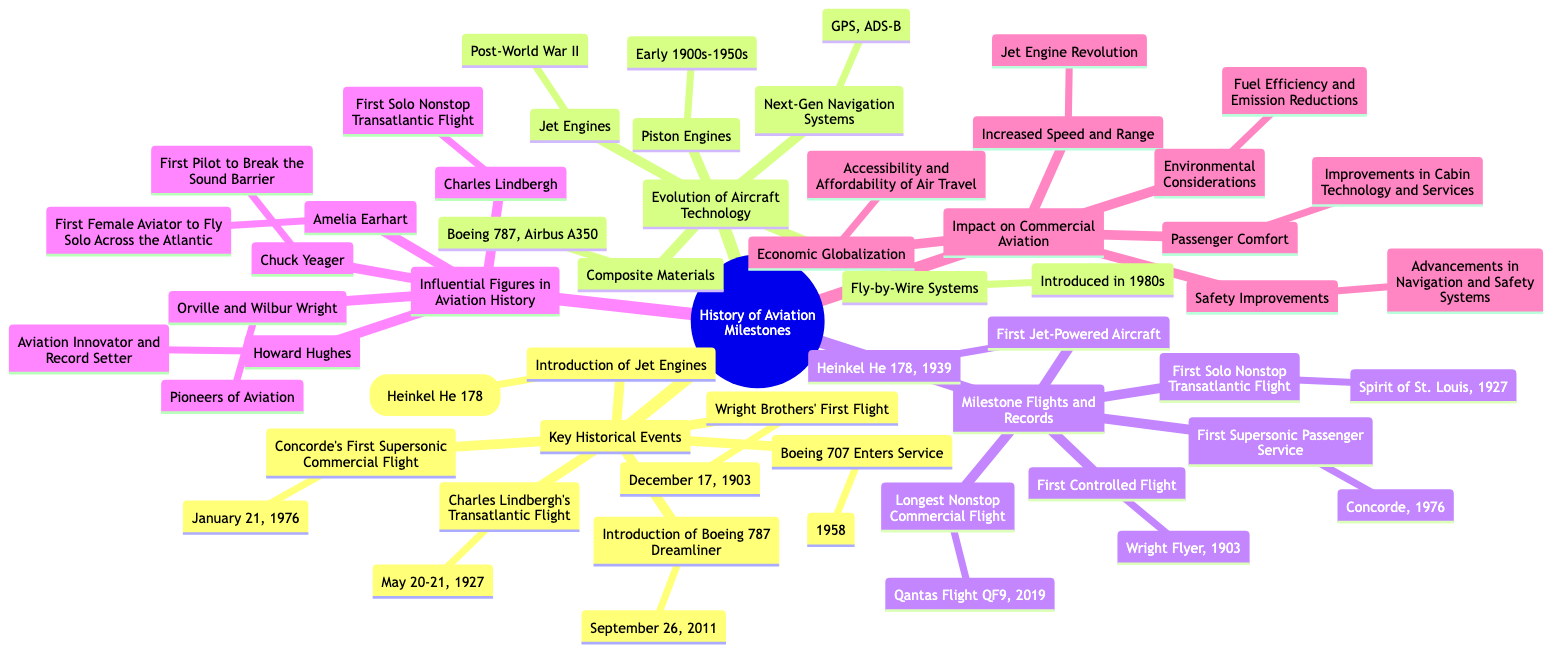What date was the Wright Brothers' First Flight? The diagram states that the date of the Wright Brothers' First Flight is December 17, 1903. This information is directly listed under the "Key Historical Events" section.
Answer: December 17, 1903 What aircraft was the first jet-powered aircraft? According to the diagram, the first jet-powered aircraft was the Heinkel He 178, which is mentioned under the "Milestone Flights and Records" section.
Answer: Heinkel He 178 Which aviation milestone occurred on January 21, 1976? The diagram shows that Concorde's First Supersonic Commercial Flight occurred on January 21, 1976, listed in the "Key Historical Events."
Answer: Concorde's First Supersonic Commercial Flight How did the introduction of jet engines impact aviation? The diagram connects the introduction of jet engines to the concept of "Increased Speed and Range" under the "Impact on Commercial Aviation." This implies that jet engines significantly increased the speed and range of aircraft.
Answer: Increased Speed and Range Who was the first female aviator to fly solo across the Atlantic? The diagram indicates that Amelia Earhart is recognized as the first female aviator to fly solo across the Atlantic. This information is found under the "Influential Figures in Aviation History."
Answer: Amelia Earhart What material innovation is used in the Boeing 787 and Airbus A350? The diagram lists "Composite Materials" as a technology innovation found in Boeing 787 and Airbus A350 under the "Evolution of Aircraft Technology."
Answer: Composite Materials What record was set by Qantas Flight QF9 in 2019? The diagram states that Qantas Flight QF9 set the record for the Longest Nonstop Commercial Flight in 2019, which is specified in the "Milestone Flights and Records" section.
Answer: Longest Nonstop Commercial Flight How are advancements in navigation and safety systems categorized? The diagram categorizes advancements in navigation and safety systems under "Safety Improvements" within the "Impact on Commercial Aviation," indicating that these advancements are recognized benefits of aviation evolution.
Answer: Safety Improvements What was the first aircraft to break the sound barrier? Chuck Yeager, listed under "Influential Figures in Aviation History," is recognized as the first pilot to break the sound barrier, thus referring to the aircraft associated with that milestone.
Answer: Unknown aircraft (not specified in the diagram) 